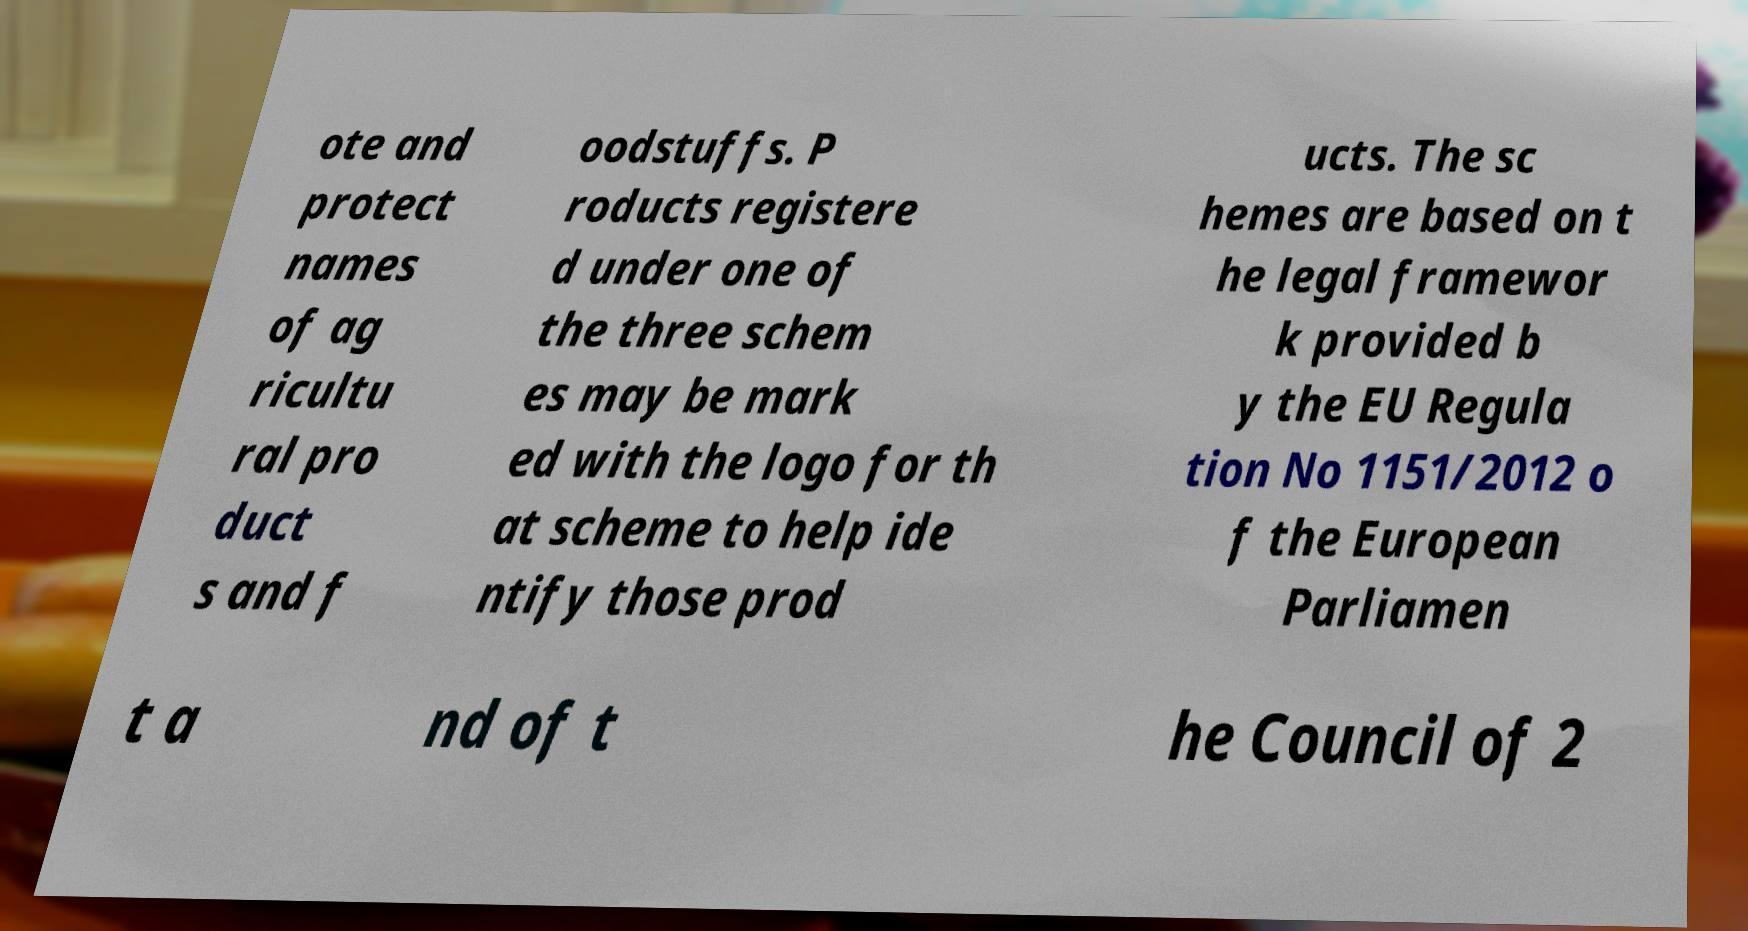What messages or text are displayed in this image? I need them in a readable, typed format. ote and protect names of ag ricultu ral pro duct s and f oodstuffs. P roducts registere d under one of the three schem es may be mark ed with the logo for th at scheme to help ide ntify those prod ucts. The sc hemes are based on t he legal framewor k provided b y the EU Regula tion No 1151/2012 o f the European Parliamen t a nd of t he Council of 2 